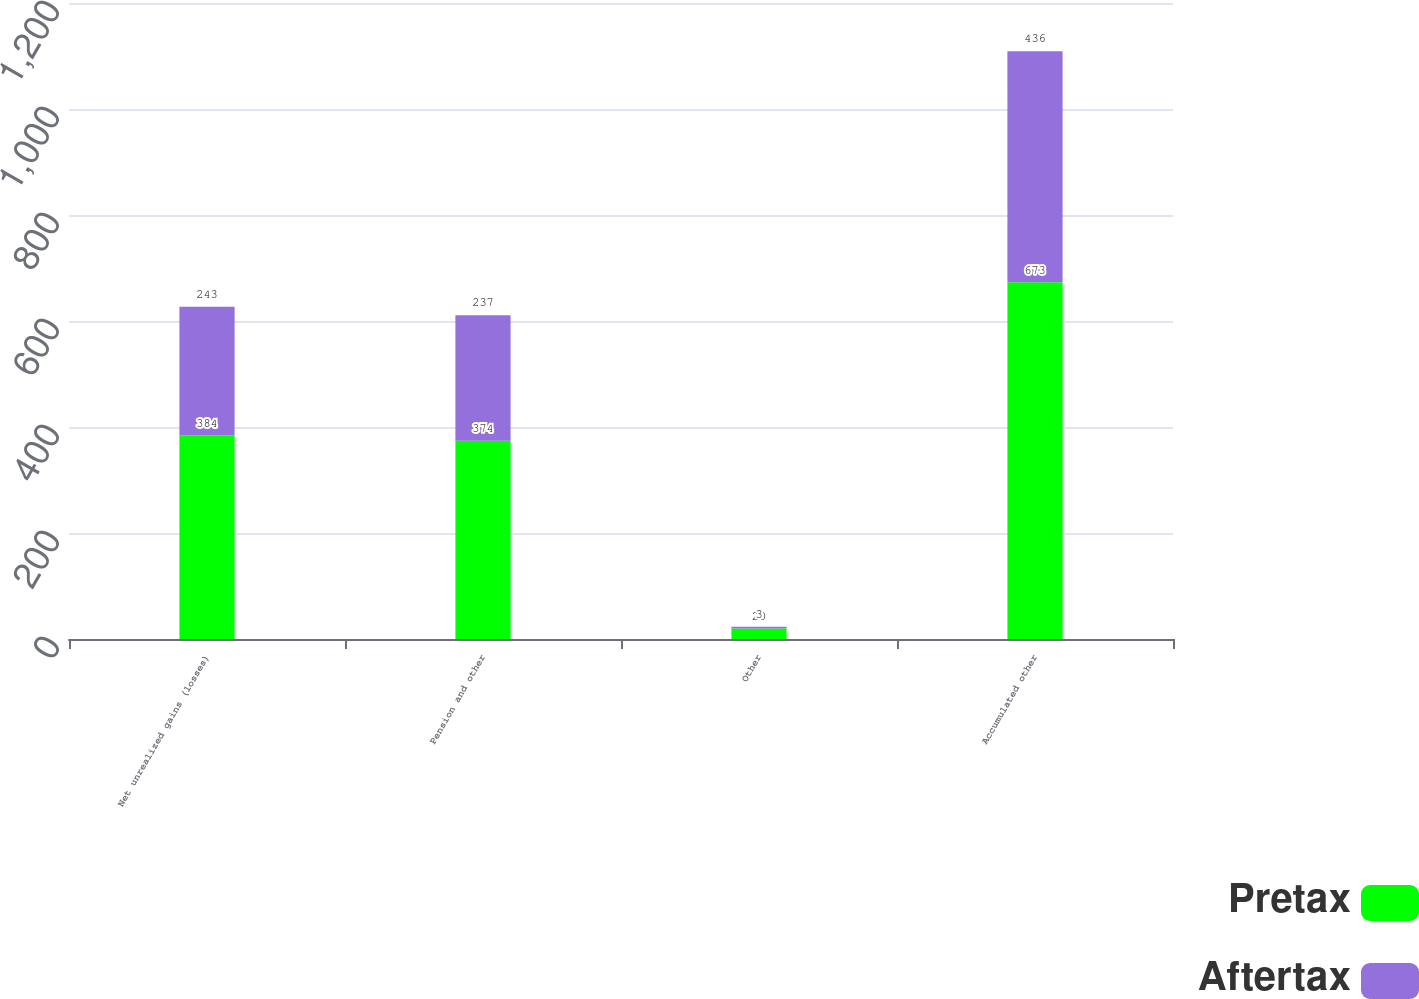Convert chart to OTSL. <chart><loc_0><loc_0><loc_500><loc_500><stacked_bar_chart><ecel><fcel>Net unrealized gains (losses)<fcel>Pension and other<fcel>Other<fcel>Accumulated other<nl><fcel>Pretax<fcel>384<fcel>374<fcel>20<fcel>673<nl><fcel>Aftertax<fcel>243<fcel>237<fcel>3<fcel>436<nl></chart> 